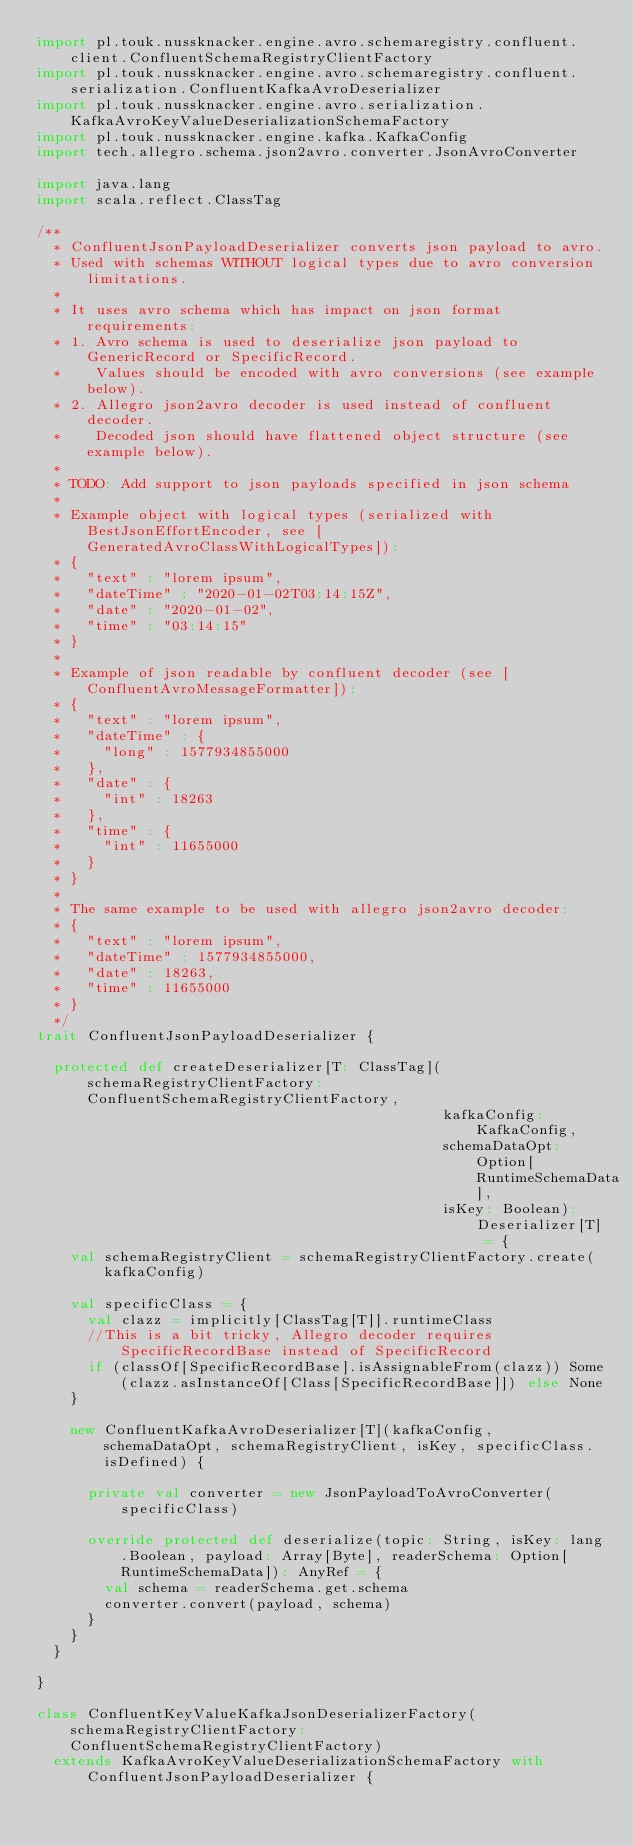Convert code to text. <code><loc_0><loc_0><loc_500><loc_500><_Scala_>import pl.touk.nussknacker.engine.avro.schemaregistry.confluent.client.ConfluentSchemaRegistryClientFactory
import pl.touk.nussknacker.engine.avro.schemaregistry.confluent.serialization.ConfluentKafkaAvroDeserializer
import pl.touk.nussknacker.engine.avro.serialization.KafkaAvroKeyValueDeserializationSchemaFactory
import pl.touk.nussknacker.engine.kafka.KafkaConfig
import tech.allegro.schema.json2avro.converter.JsonAvroConverter

import java.lang
import scala.reflect.ClassTag

/**
  * ConfluentJsonPayloadDeserializer converts json payload to avro.
  * Used with schemas WITHOUT logical types due to avro conversion limitations.
  *
  * It uses avro schema which has impact on json format requirements:
  * 1. Avro schema is used to deserialize json payload to GenericRecord or SpecificRecord.
  *    Values should be encoded with avro conversions (see example below).
  * 2. Allegro json2avro decoder is used instead of confluent decoder.
  *    Decoded json should have flattened object structure (see example below).
  *
  * TODO: Add support to json payloads specified in json schema
  *
  * Example object with logical types (serialized with BestJsonEffortEncoder, see [GeneratedAvroClassWithLogicalTypes]):
  * {
  *   "text" : "lorem ipsum",
  *   "dateTime" : "2020-01-02T03:14:15Z",
  *   "date" : "2020-01-02",
  *   "time" : "03:14:15"
  * }
  *
  * Example of json readable by confluent decoder (see [ConfluentAvroMessageFormatter]):
  * {
  *   "text" : "lorem ipsum",
  *   "dateTime" : {
  *     "long" : 1577934855000
  *   },
  *   "date" : {
  *     "int" : 18263
  *   },
  *   "time" : {
  *     "int" : 11655000
  *   }
  * }
  *
  * The same example to be used with allegro json2avro decoder:
  * {
  *   "text" : "lorem ipsum",
  *   "dateTime" : 1577934855000,
  *   "date" : 18263,
  *   "time" : 11655000
  * }
  */
trait ConfluentJsonPayloadDeserializer {

  protected def createDeserializer[T: ClassTag](schemaRegistryClientFactory: ConfluentSchemaRegistryClientFactory,
                                                kafkaConfig: KafkaConfig,
                                                schemaDataOpt: Option[RuntimeSchemaData],
                                                isKey: Boolean): Deserializer[T] = {
    val schemaRegistryClient = schemaRegistryClientFactory.create(kafkaConfig)

    val specificClass = {
      val clazz = implicitly[ClassTag[T]].runtimeClass
      //This is a bit tricky, Allegro decoder requires SpecificRecordBase instead of SpecificRecord
      if (classOf[SpecificRecordBase].isAssignableFrom(clazz)) Some(clazz.asInstanceOf[Class[SpecificRecordBase]]) else None
    }

    new ConfluentKafkaAvroDeserializer[T](kafkaConfig, schemaDataOpt, schemaRegistryClient, isKey, specificClass.isDefined) {

      private val converter = new JsonPayloadToAvroConverter(specificClass)

      override protected def deserialize(topic: String, isKey: lang.Boolean, payload: Array[Byte], readerSchema: Option[RuntimeSchemaData]): AnyRef = {
        val schema = readerSchema.get.schema
        converter.convert(payload, schema)
      }
    }
  }

}

class ConfluentKeyValueKafkaJsonDeserializerFactory(schemaRegistryClientFactory: ConfluentSchemaRegistryClientFactory)
  extends KafkaAvroKeyValueDeserializationSchemaFactory with ConfluentJsonPayloadDeserializer {
</code> 